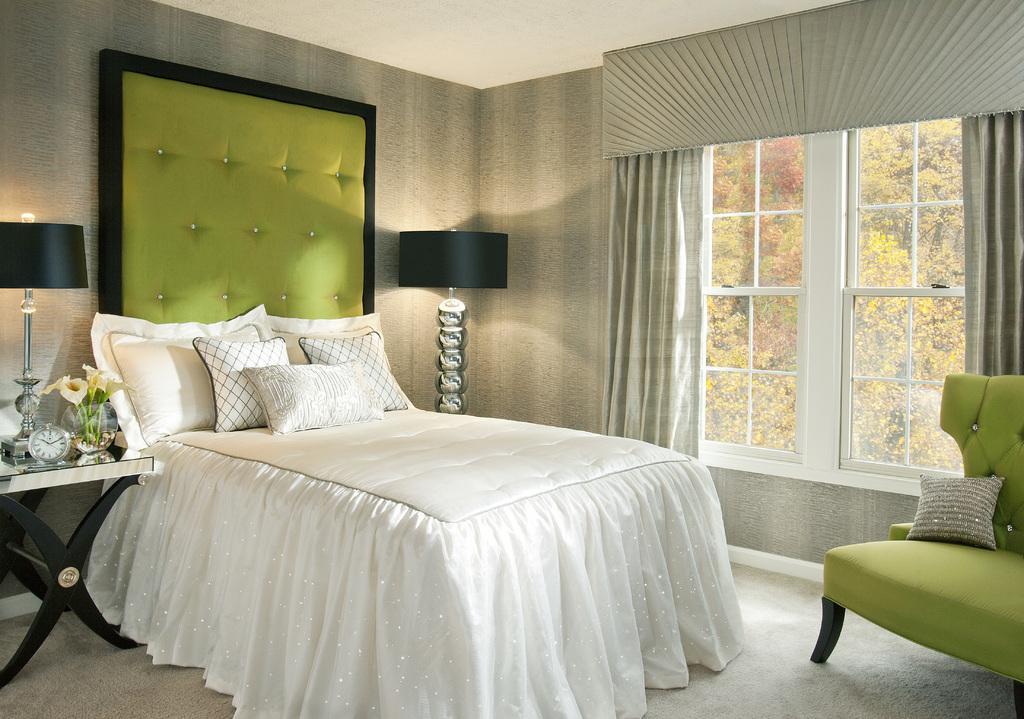Please provide a concise description of this image. In this picture this is inside the house. We can see the bed. On the bed we can see pillows. On the background we can see wall. There is a table. On the table we can see lamp,clock,flowers. There is a window. From this window we can see trees. there is a chair. On the chair we can see pillow. This is floor. 